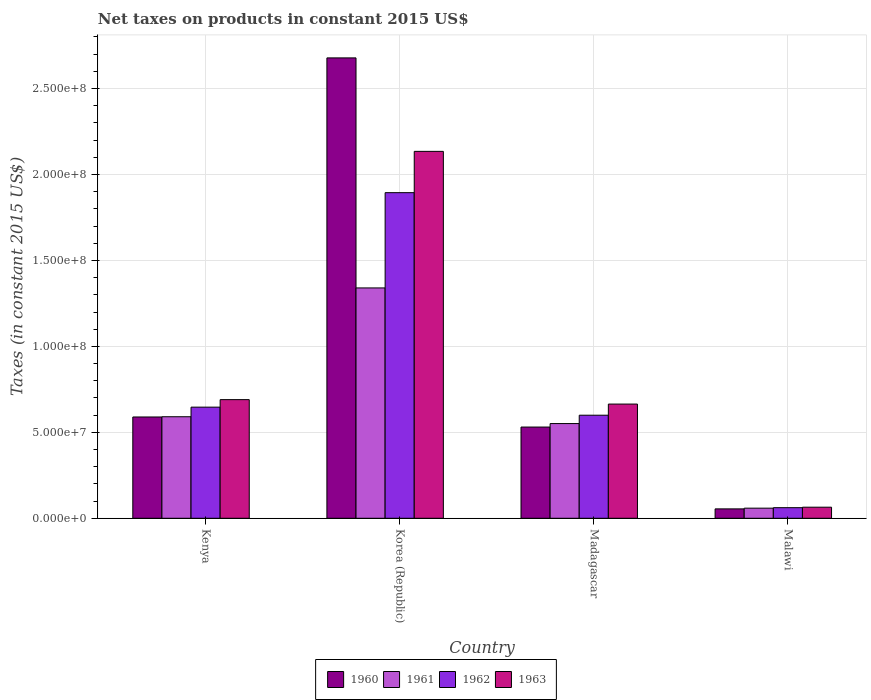How many different coloured bars are there?
Your response must be concise. 4. Are the number of bars per tick equal to the number of legend labels?
Your answer should be compact. Yes. Are the number of bars on each tick of the X-axis equal?
Ensure brevity in your answer.  Yes. How many bars are there on the 2nd tick from the right?
Provide a succinct answer. 4. What is the label of the 3rd group of bars from the left?
Provide a succinct answer. Madagascar. What is the net taxes on products in 1960 in Malawi?
Your response must be concise. 5.46e+06. Across all countries, what is the maximum net taxes on products in 1960?
Your answer should be compact. 2.68e+08. Across all countries, what is the minimum net taxes on products in 1962?
Offer a terse response. 6.16e+06. In which country was the net taxes on products in 1960 minimum?
Ensure brevity in your answer.  Malawi. What is the total net taxes on products in 1960 in the graph?
Your answer should be compact. 3.85e+08. What is the difference between the net taxes on products in 1963 in Madagascar and that in Malawi?
Your response must be concise. 6.00e+07. What is the difference between the net taxes on products in 1963 in Madagascar and the net taxes on products in 1961 in Kenya?
Give a very brief answer. 7.37e+06. What is the average net taxes on products in 1961 per country?
Keep it short and to the point. 6.35e+07. What is the difference between the net taxes on products of/in 1960 and net taxes on products of/in 1962 in Kenya?
Keep it short and to the point. -5.73e+06. In how many countries, is the net taxes on products in 1960 greater than 110000000 US$?
Keep it short and to the point. 1. What is the ratio of the net taxes on products in 1960 in Kenya to that in Korea (Republic)?
Your answer should be compact. 0.22. Is the net taxes on products in 1962 in Kenya less than that in Madagascar?
Provide a succinct answer. No. What is the difference between the highest and the second highest net taxes on products in 1962?
Provide a short and direct response. 1.29e+08. What is the difference between the highest and the lowest net taxes on products in 1961?
Your response must be concise. 1.28e+08. Is it the case that in every country, the sum of the net taxes on products in 1960 and net taxes on products in 1961 is greater than the sum of net taxes on products in 1963 and net taxes on products in 1962?
Ensure brevity in your answer.  No. What does the 2nd bar from the left in Malawi represents?
Offer a terse response. 1961. What does the 3rd bar from the right in Madagascar represents?
Provide a short and direct response. 1961. Is it the case that in every country, the sum of the net taxes on products in 1962 and net taxes on products in 1963 is greater than the net taxes on products in 1960?
Your response must be concise. Yes. Are all the bars in the graph horizontal?
Ensure brevity in your answer.  No. How many countries are there in the graph?
Give a very brief answer. 4. What is the difference between two consecutive major ticks on the Y-axis?
Give a very brief answer. 5.00e+07. Are the values on the major ticks of Y-axis written in scientific E-notation?
Your answer should be very brief. Yes. Does the graph contain any zero values?
Give a very brief answer. No. How many legend labels are there?
Offer a very short reply. 4. How are the legend labels stacked?
Ensure brevity in your answer.  Horizontal. What is the title of the graph?
Offer a very short reply. Net taxes on products in constant 2015 US$. Does "2007" appear as one of the legend labels in the graph?
Offer a very short reply. No. What is the label or title of the Y-axis?
Offer a terse response. Taxes (in constant 2015 US$). What is the Taxes (in constant 2015 US$) of 1960 in Kenya?
Provide a short and direct response. 5.89e+07. What is the Taxes (in constant 2015 US$) in 1961 in Kenya?
Ensure brevity in your answer.  5.91e+07. What is the Taxes (in constant 2015 US$) in 1962 in Kenya?
Offer a very short reply. 6.47e+07. What is the Taxes (in constant 2015 US$) in 1963 in Kenya?
Keep it short and to the point. 6.90e+07. What is the Taxes (in constant 2015 US$) of 1960 in Korea (Republic)?
Keep it short and to the point. 2.68e+08. What is the Taxes (in constant 2015 US$) of 1961 in Korea (Republic)?
Your response must be concise. 1.34e+08. What is the Taxes (in constant 2015 US$) in 1962 in Korea (Republic)?
Offer a terse response. 1.89e+08. What is the Taxes (in constant 2015 US$) in 1963 in Korea (Republic)?
Provide a short and direct response. 2.13e+08. What is the Taxes (in constant 2015 US$) in 1960 in Madagascar?
Ensure brevity in your answer.  5.31e+07. What is the Taxes (in constant 2015 US$) of 1961 in Madagascar?
Offer a terse response. 5.51e+07. What is the Taxes (in constant 2015 US$) of 1962 in Madagascar?
Make the answer very short. 6.00e+07. What is the Taxes (in constant 2015 US$) of 1963 in Madagascar?
Make the answer very short. 6.64e+07. What is the Taxes (in constant 2015 US$) of 1960 in Malawi?
Your answer should be very brief. 5.46e+06. What is the Taxes (in constant 2015 US$) in 1961 in Malawi?
Offer a very short reply. 5.88e+06. What is the Taxes (in constant 2015 US$) in 1962 in Malawi?
Offer a terse response. 6.16e+06. What is the Taxes (in constant 2015 US$) of 1963 in Malawi?
Ensure brevity in your answer.  6.44e+06. Across all countries, what is the maximum Taxes (in constant 2015 US$) in 1960?
Your response must be concise. 2.68e+08. Across all countries, what is the maximum Taxes (in constant 2015 US$) of 1961?
Offer a very short reply. 1.34e+08. Across all countries, what is the maximum Taxes (in constant 2015 US$) of 1962?
Ensure brevity in your answer.  1.89e+08. Across all countries, what is the maximum Taxes (in constant 2015 US$) of 1963?
Provide a succinct answer. 2.13e+08. Across all countries, what is the minimum Taxes (in constant 2015 US$) of 1960?
Offer a very short reply. 5.46e+06. Across all countries, what is the minimum Taxes (in constant 2015 US$) in 1961?
Offer a very short reply. 5.88e+06. Across all countries, what is the minimum Taxes (in constant 2015 US$) in 1962?
Your response must be concise. 6.16e+06. Across all countries, what is the minimum Taxes (in constant 2015 US$) in 1963?
Your answer should be compact. 6.44e+06. What is the total Taxes (in constant 2015 US$) in 1960 in the graph?
Your answer should be very brief. 3.85e+08. What is the total Taxes (in constant 2015 US$) in 1961 in the graph?
Give a very brief answer. 2.54e+08. What is the total Taxes (in constant 2015 US$) of 1962 in the graph?
Offer a terse response. 3.20e+08. What is the total Taxes (in constant 2015 US$) in 1963 in the graph?
Your response must be concise. 3.55e+08. What is the difference between the Taxes (in constant 2015 US$) of 1960 in Kenya and that in Korea (Republic)?
Make the answer very short. -2.09e+08. What is the difference between the Taxes (in constant 2015 US$) in 1961 in Kenya and that in Korea (Republic)?
Your response must be concise. -7.49e+07. What is the difference between the Taxes (in constant 2015 US$) of 1962 in Kenya and that in Korea (Republic)?
Ensure brevity in your answer.  -1.25e+08. What is the difference between the Taxes (in constant 2015 US$) in 1963 in Kenya and that in Korea (Republic)?
Offer a very short reply. -1.44e+08. What is the difference between the Taxes (in constant 2015 US$) of 1960 in Kenya and that in Madagascar?
Offer a very short reply. 5.86e+06. What is the difference between the Taxes (in constant 2015 US$) of 1961 in Kenya and that in Madagascar?
Your answer should be very brief. 3.97e+06. What is the difference between the Taxes (in constant 2015 US$) in 1962 in Kenya and that in Madagascar?
Keep it short and to the point. 4.70e+06. What is the difference between the Taxes (in constant 2015 US$) in 1963 in Kenya and that in Madagascar?
Provide a succinct answer. 2.58e+06. What is the difference between the Taxes (in constant 2015 US$) in 1960 in Kenya and that in Malawi?
Your answer should be very brief. 5.35e+07. What is the difference between the Taxes (in constant 2015 US$) in 1961 in Kenya and that in Malawi?
Offer a very short reply. 5.32e+07. What is the difference between the Taxes (in constant 2015 US$) of 1962 in Kenya and that in Malawi?
Your response must be concise. 5.85e+07. What is the difference between the Taxes (in constant 2015 US$) in 1963 in Kenya and that in Malawi?
Ensure brevity in your answer.  6.26e+07. What is the difference between the Taxes (in constant 2015 US$) in 1960 in Korea (Republic) and that in Madagascar?
Your answer should be very brief. 2.15e+08. What is the difference between the Taxes (in constant 2015 US$) in 1961 in Korea (Republic) and that in Madagascar?
Your response must be concise. 7.89e+07. What is the difference between the Taxes (in constant 2015 US$) in 1962 in Korea (Republic) and that in Madagascar?
Provide a short and direct response. 1.29e+08. What is the difference between the Taxes (in constant 2015 US$) in 1963 in Korea (Republic) and that in Madagascar?
Ensure brevity in your answer.  1.47e+08. What is the difference between the Taxes (in constant 2015 US$) in 1960 in Korea (Republic) and that in Malawi?
Ensure brevity in your answer.  2.62e+08. What is the difference between the Taxes (in constant 2015 US$) of 1961 in Korea (Republic) and that in Malawi?
Your answer should be compact. 1.28e+08. What is the difference between the Taxes (in constant 2015 US$) in 1962 in Korea (Republic) and that in Malawi?
Your answer should be compact. 1.83e+08. What is the difference between the Taxes (in constant 2015 US$) of 1963 in Korea (Republic) and that in Malawi?
Make the answer very short. 2.07e+08. What is the difference between the Taxes (in constant 2015 US$) in 1960 in Madagascar and that in Malawi?
Your response must be concise. 4.76e+07. What is the difference between the Taxes (in constant 2015 US$) in 1961 in Madagascar and that in Malawi?
Make the answer very short. 4.92e+07. What is the difference between the Taxes (in constant 2015 US$) of 1962 in Madagascar and that in Malawi?
Give a very brief answer. 5.38e+07. What is the difference between the Taxes (in constant 2015 US$) in 1963 in Madagascar and that in Malawi?
Your answer should be very brief. 6.00e+07. What is the difference between the Taxes (in constant 2015 US$) in 1960 in Kenya and the Taxes (in constant 2015 US$) in 1961 in Korea (Republic)?
Make the answer very short. -7.51e+07. What is the difference between the Taxes (in constant 2015 US$) of 1960 in Kenya and the Taxes (in constant 2015 US$) of 1962 in Korea (Republic)?
Keep it short and to the point. -1.31e+08. What is the difference between the Taxes (in constant 2015 US$) of 1960 in Kenya and the Taxes (in constant 2015 US$) of 1963 in Korea (Republic)?
Offer a very short reply. -1.55e+08. What is the difference between the Taxes (in constant 2015 US$) of 1961 in Kenya and the Taxes (in constant 2015 US$) of 1962 in Korea (Republic)?
Your answer should be compact. -1.30e+08. What is the difference between the Taxes (in constant 2015 US$) in 1961 in Kenya and the Taxes (in constant 2015 US$) in 1963 in Korea (Republic)?
Your response must be concise. -1.54e+08. What is the difference between the Taxes (in constant 2015 US$) of 1962 in Kenya and the Taxes (in constant 2015 US$) of 1963 in Korea (Republic)?
Provide a succinct answer. -1.49e+08. What is the difference between the Taxes (in constant 2015 US$) in 1960 in Kenya and the Taxes (in constant 2015 US$) in 1961 in Madagascar?
Ensure brevity in your answer.  3.83e+06. What is the difference between the Taxes (in constant 2015 US$) of 1960 in Kenya and the Taxes (in constant 2015 US$) of 1962 in Madagascar?
Provide a succinct answer. -1.03e+06. What is the difference between the Taxes (in constant 2015 US$) of 1960 in Kenya and the Taxes (in constant 2015 US$) of 1963 in Madagascar?
Offer a terse response. -7.51e+06. What is the difference between the Taxes (in constant 2015 US$) in 1961 in Kenya and the Taxes (in constant 2015 US$) in 1962 in Madagascar?
Offer a very short reply. -8.90e+05. What is the difference between the Taxes (in constant 2015 US$) of 1961 in Kenya and the Taxes (in constant 2015 US$) of 1963 in Madagascar?
Offer a very short reply. -7.37e+06. What is the difference between the Taxes (in constant 2015 US$) of 1962 in Kenya and the Taxes (in constant 2015 US$) of 1963 in Madagascar?
Give a very brief answer. -1.79e+06. What is the difference between the Taxes (in constant 2015 US$) in 1960 in Kenya and the Taxes (in constant 2015 US$) in 1961 in Malawi?
Keep it short and to the point. 5.30e+07. What is the difference between the Taxes (in constant 2015 US$) of 1960 in Kenya and the Taxes (in constant 2015 US$) of 1962 in Malawi?
Your answer should be very brief. 5.28e+07. What is the difference between the Taxes (in constant 2015 US$) of 1960 in Kenya and the Taxes (in constant 2015 US$) of 1963 in Malawi?
Provide a short and direct response. 5.25e+07. What is the difference between the Taxes (in constant 2015 US$) in 1961 in Kenya and the Taxes (in constant 2015 US$) in 1962 in Malawi?
Give a very brief answer. 5.29e+07. What is the difference between the Taxes (in constant 2015 US$) of 1961 in Kenya and the Taxes (in constant 2015 US$) of 1963 in Malawi?
Ensure brevity in your answer.  5.26e+07. What is the difference between the Taxes (in constant 2015 US$) of 1962 in Kenya and the Taxes (in constant 2015 US$) of 1963 in Malawi?
Provide a short and direct response. 5.82e+07. What is the difference between the Taxes (in constant 2015 US$) of 1960 in Korea (Republic) and the Taxes (in constant 2015 US$) of 1961 in Madagascar?
Offer a terse response. 2.13e+08. What is the difference between the Taxes (in constant 2015 US$) in 1960 in Korea (Republic) and the Taxes (in constant 2015 US$) in 1962 in Madagascar?
Keep it short and to the point. 2.08e+08. What is the difference between the Taxes (in constant 2015 US$) in 1960 in Korea (Republic) and the Taxes (in constant 2015 US$) in 1963 in Madagascar?
Make the answer very short. 2.01e+08. What is the difference between the Taxes (in constant 2015 US$) of 1961 in Korea (Republic) and the Taxes (in constant 2015 US$) of 1962 in Madagascar?
Your answer should be very brief. 7.41e+07. What is the difference between the Taxes (in constant 2015 US$) of 1961 in Korea (Republic) and the Taxes (in constant 2015 US$) of 1963 in Madagascar?
Your answer should be very brief. 6.76e+07. What is the difference between the Taxes (in constant 2015 US$) in 1962 in Korea (Republic) and the Taxes (in constant 2015 US$) in 1963 in Madagascar?
Offer a terse response. 1.23e+08. What is the difference between the Taxes (in constant 2015 US$) of 1960 in Korea (Republic) and the Taxes (in constant 2015 US$) of 1961 in Malawi?
Make the answer very short. 2.62e+08. What is the difference between the Taxes (in constant 2015 US$) of 1960 in Korea (Republic) and the Taxes (in constant 2015 US$) of 1962 in Malawi?
Give a very brief answer. 2.62e+08. What is the difference between the Taxes (in constant 2015 US$) of 1960 in Korea (Republic) and the Taxes (in constant 2015 US$) of 1963 in Malawi?
Keep it short and to the point. 2.61e+08. What is the difference between the Taxes (in constant 2015 US$) of 1961 in Korea (Republic) and the Taxes (in constant 2015 US$) of 1962 in Malawi?
Your response must be concise. 1.28e+08. What is the difference between the Taxes (in constant 2015 US$) of 1961 in Korea (Republic) and the Taxes (in constant 2015 US$) of 1963 in Malawi?
Offer a very short reply. 1.28e+08. What is the difference between the Taxes (in constant 2015 US$) in 1962 in Korea (Republic) and the Taxes (in constant 2015 US$) in 1963 in Malawi?
Provide a short and direct response. 1.83e+08. What is the difference between the Taxes (in constant 2015 US$) of 1960 in Madagascar and the Taxes (in constant 2015 US$) of 1961 in Malawi?
Your answer should be compact. 4.72e+07. What is the difference between the Taxes (in constant 2015 US$) in 1960 in Madagascar and the Taxes (in constant 2015 US$) in 1962 in Malawi?
Keep it short and to the point. 4.69e+07. What is the difference between the Taxes (in constant 2015 US$) of 1960 in Madagascar and the Taxes (in constant 2015 US$) of 1963 in Malawi?
Your answer should be very brief. 4.66e+07. What is the difference between the Taxes (in constant 2015 US$) in 1961 in Madagascar and the Taxes (in constant 2015 US$) in 1962 in Malawi?
Make the answer very short. 4.89e+07. What is the difference between the Taxes (in constant 2015 US$) in 1961 in Madagascar and the Taxes (in constant 2015 US$) in 1963 in Malawi?
Your answer should be compact. 4.87e+07. What is the difference between the Taxes (in constant 2015 US$) in 1962 in Madagascar and the Taxes (in constant 2015 US$) in 1963 in Malawi?
Your answer should be compact. 5.35e+07. What is the average Taxes (in constant 2015 US$) in 1960 per country?
Give a very brief answer. 9.63e+07. What is the average Taxes (in constant 2015 US$) of 1961 per country?
Keep it short and to the point. 6.35e+07. What is the average Taxes (in constant 2015 US$) of 1962 per country?
Make the answer very short. 8.00e+07. What is the average Taxes (in constant 2015 US$) in 1963 per country?
Your response must be concise. 8.88e+07. What is the difference between the Taxes (in constant 2015 US$) in 1960 and Taxes (in constant 2015 US$) in 1961 in Kenya?
Keep it short and to the point. -1.40e+05. What is the difference between the Taxes (in constant 2015 US$) in 1960 and Taxes (in constant 2015 US$) in 1962 in Kenya?
Your answer should be very brief. -5.73e+06. What is the difference between the Taxes (in constant 2015 US$) in 1960 and Taxes (in constant 2015 US$) in 1963 in Kenya?
Keep it short and to the point. -1.01e+07. What is the difference between the Taxes (in constant 2015 US$) in 1961 and Taxes (in constant 2015 US$) in 1962 in Kenya?
Provide a succinct answer. -5.59e+06. What is the difference between the Taxes (in constant 2015 US$) of 1961 and Taxes (in constant 2015 US$) of 1963 in Kenya?
Give a very brief answer. -9.95e+06. What is the difference between the Taxes (in constant 2015 US$) of 1962 and Taxes (in constant 2015 US$) of 1963 in Kenya?
Keep it short and to the point. -4.37e+06. What is the difference between the Taxes (in constant 2015 US$) of 1960 and Taxes (in constant 2015 US$) of 1961 in Korea (Republic)?
Your response must be concise. 1.34e+08. What is the difference between the Taxes (in constant 2015 US$) of 1960 and Taxes (in constant 2015 US$) of 1962 in Korea (Republic)?
Ensure brevity in your answer.  7.84e+07. What is the difference between the Taxes (in constant 2015 US$) of 1960 and Taxes (in constant 2015 US$) of 1963 in Korea (Republic)?
Offer a very short reply. 5.44e+07. What is the difference between the Taxes (in constant 2015 US$) in 1961 and Taxes (in constant 2015 US$) in 1962 in Korea (Republic)?
Provide a succinct answer. -5.54e+07. What is the difference between the Taxes (in constant 2015 US$) in 1961 and Taxes (in constant 2015 US$) in 1963 in Korea (Republic)?
Give a very brief answer. -7.94e+07. What is the difference between the Taxes (in constant 2015 US$) of 1962 and Taxes (in constant 2015 US$) of 1963 in Korea (Republic)?
Make the answer very short. -2.40e+07. What is the difference between the Taxes (in constant 2015 US$) of 1960 and Taxes (in constant 2015 US$) of 1961 in Madagascar?
Provide a succinct answer. -2.03e+06. What is the difference between the Taxes (in constant 2015 US$) in 1960 and Taxes (in constant 2015 US$) in 1962 in Madagascar?
Your answer should be very brief. -6.89e+06. What is the difference between the Taxes (in constant 2015 US$) of 1960 and Taxes (in constant 2015 US$) of 1963 in Madagascar?
Provide a short and direct response. -1.34e+07. What is the difference between the Taxes (in constant 2015 US$) in 1961 and Taxes (in constant 2015 US$) in 1962 in Madagascar?
Keep it short and to the point. -4.86e+06. What is the difference between the Taxes (in constant 2015 US$) of 1961 and Taxes (in constant 2015 US$) of 1963 in Madagascar?
Provide a succinct answer. -1.13e+07. What is the difference between the Taxes (in constant 2015 US$) of 1962 and Taxes (in constant 2015 US$) of 1963 in Madagascar?
Provide a succinct answer. -6.48e+06. What is the difference between the Taxes (in constant 2015 US$) in 1960 and Taxes (in constant 2015 US$) in 1961 in Malawi?
Your answer should be very brief. -4.20e+05. What is the difference between the Taxes (in constant 2015 US$) in 1960 and Taxes (in constant 2015 US$) in 1962 in Malawi?
Make the answer very short. -7.00e+05. What is the difference between the Taxes (in constant 2015 US$) in 1960 and Taxes (in constant 2015 US$) in 1963 in Malawi?
Give a very brief answer. -9.80e+05. What is the difference between the Taxes (in constant 2015 US$) in 1961 and Taxes (in constant 2015 US$) in 1962 in Malawi?
Ensure brevity in your answer.  -2.80e+05. What is the difference between the Taxes (in constant 2015 US$) in 1961 and Taxes (in constant 2015 US$) in 1963 in Malawi?
Your answer should be very brief. -5.60e+05. What is the difference between the Taxes (in constant 2015 US$) in 1962 and Taxes (in constant 2015 US$) in 1963 in Malawi?
Give a very brief answer. -2.80e+05. What is the ratio of the Taxes (in constant 2015 US$) of 1960 in Kenya to that in Korea (Republic)?
Ensure brevity in your answer.  0.22. What is the ratio of the Taxes (in constant 2015 US$) of 1961 in Kenya to that in Korea (Republic)?
Provide a short and direct response. 0.44. What is the ratio of the Taxes (in constant 2015 US$) in 1962 in Kenya to that in Korea (Republic)?
Your response must be concise. 0.34. What is the ratio of the Taxes (in constant 2015 US$) of 1963 in Kenya to that in Korea (Republic)?
Provide a succinct answer. 0.32. What is the ratio of the Taxes (in constant 2015 US$) in 1960 in Kenya to that in Madagascar?
Offer a terse response. 1.11. What is the ratio of the Taxes (in constant 2015 US$) of 1961 in Kenya to that in Madagascar?
Your answer should be very brief. 1.07. What is the ratio of the Taxes (in constant 2015 US$) in 1962 in Kenya to that in Madagascar?
Your answer should be very brief. 1.08. What is the ratio of the Taxes (in constant 2015 US$) in 1963 in Kenya to that in Madagascar?
Your answer should be compact. 1.04. What is the ratio of the Taxes (in constant 2015 US$) in 1960 in Kenya to that in Malawi?
Offer a very short reply. 10.79. What is the ratio of the Taxes (in constant 2015 US$) of 1961 in Kenya to that in Malawi?
Provide a succinct answer. 10.05. What is the ratio of the Taxes (in constant 2015 US$) in 1962 in Kenya to that in Malawi?
Give a very brief answer. 10.5. What is the ratio of the Taxes (in constant 2015 US$) of 1963 in Kenya to that in Malawi?
Your answer should be compact. 10.72. What is the ratio of the Taxes (in constant 2015 US$) in 1960 in Korea (Republic) to that in Madagascar?
Offer a terse response. 5.05. What is the ratio of the Taxes (in constant 2015 US$) in 1961 in Korea (Republic) to that in Madagascar?
Offer a very short reply. 2.43. What is the ratio of the Taxes (in constant 2015 US$) of 1962 in Korea (Republic) to that in Madagascar?
Offer a terse response. 3.16. What is the ratio of the Taxes (in constant 2015 US$) in 1963 in Korea (Republic) to that in Madagascar?
Provide a short and direct response. 3.21. What is the ratio of the Taxes (in constant 2015 US$) in 1960 in Korea (Republic) to that in Malawi?
Provide a succinct answer. 49.05. What is the ratio of the Taxes (in constant 2015 US$) in 1961 in Korea (Republic) to that in Malawi?
Offer a terse response. 22.79. What is the ratio of the Taxes (in constant 2015 US$) in 1962 in Korea (Republic) to that in Malawi?
Your answer should be compact. 30.75. What is the ratio of the Taxes (in constant 2015 US$) in 1963 in Korea (Republic) to that in Malawi?
Offer a terse response. 33.15. What is the ratio of the Taxes (in constant 2015 US$) of 1960 in Madagascar to that in Malawi?
Provide a short and direct response. 9.72. What is the ratio of the Taxes (in constant 2015 US$) in 1961 in Madagascar to that in Malawi?
Make the answer very short. 9.37. What is the ratio of the Taxes (in constant 2015 US$) in 1962 in Madagascar to that in Malawi?
Ensure brevity in your answer.  9.73. What is the ratio of the Taxes (in constant 2015 US$) in 1963 in Madagascar to that in Malawi?
Provide a short and direct response. 10.32. What is the difference between the highest and the second highest Taxes (in constant 2015 US$) of 1960?
Your response must be concise. 2.09e+08. What is the difference between the highest and the second highest Taxes (in constant 2015 US$) of 1961?
Offer a terse response. 7.49e+07. What is the difference between the highest and the second highest Taxes (in constant 2015 US$) in 1962?
Provide a succinct answer. 1.25e+08. What is the difference between the highest and the second highest Taxes (in constant 2015 US$) in 1963?
Your answer should be very brief. 1.44e+08. What is the difference between the highest and the lowest Taxes (in constant 2015 US$) in 1960?
Provide a succinct answer. 2.62e+08. What is the difference between the highest and the lowest Taxes (in constant 2015 US$) in 1961?
Offer a very short reply. 1.28e+08. What is the difference between the highest and the lowest Taxes (in constant 2015 US$) of 1962?
Ensure brevity in your answer.  1.83e+08. What is the difference between the highest and the lowest Taxes (in constant 2015 US$) in 1963?
Your answer should be very brief. 2.07e+08. 